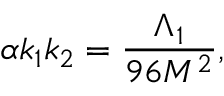Convert formula to latex. <formula><loc_0><loc_0><loc_500><loc_500>\alpha k _ { 1 } k _ { 2 } = \frac { \Lambda _ { 1 } } { 9 6 M ^ { 2 } } ,</formula> 